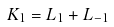<formula> <loc_0><loc_0><loc_500><loc_500>K _ { 1 } = L _ { 1 } + L _ { - 1 }</formula> 